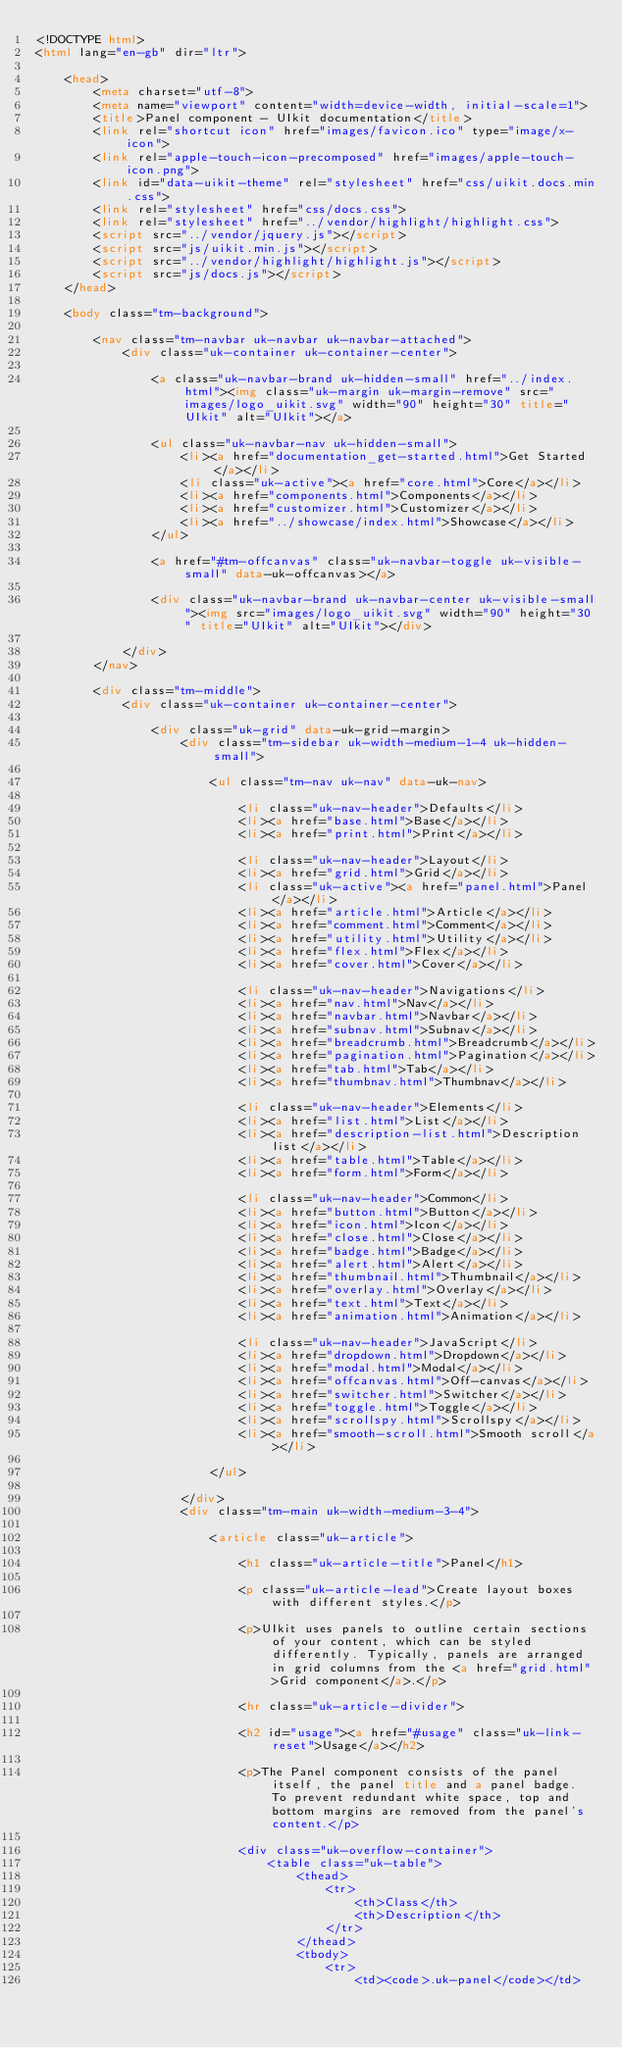<code> <loc_0><loc_0><loc_500><loc_500><_HTML_><!DOCTYPE html>
<html lang="en-gb" dir="ltr">

    <head>
        <meta charset="utf-8">
        <meta name="viewport" content="width=device-width, initial-scale=1">
        <title>Panel component - UIkit documentation</title>
        <link rel="shortcut icon" href="images/favicon.ico" type="image/x-icon">
        <link rel="apple-touch-icon-precomposed" href="images/apple-touch-icon.png">
        <link id="data-uikit-theme" rel="stylesheet" href="css/uikit.docs.min.css">
        <link rel="stylesheet" href="css/docs.css">
        <link rel="stylesheet" href="../vendor/highlight/highlight.css">
        <script src="../vendor/jquery.js"></script>
        <script src="js/uikit.min.js"></script>
        <script src="../vendor/highlight/highlight.js"></script>
        <script src="js/docs.js"></script>
    </head>

    <body class="tm-background">

        <nav class="tm-navbar uk-navbar uk-navbar-attached">
            <div class="uk-container uk-container-center">

                <a class="uk-navbar-brand uk-hidden-small" href="../index.html"><img class="uk-margin uk-margin-remove" src="images/logo_uikit.svg" width="90" height="30" title="UIkit" alt="UIkit"></a>

                <ul class="uk-navbar-nav uk-hidden-small">
                    <li><a href="documentation_get-started.html">Get Started</a></li>
                    <li class="uk-active"><a href="core.html">Core</a></li>
                    <li><a href="components.html">Components</a></li>
                    <li><a href="customizer.html">Customizer</a></li>
                    <li><a href="../showcase/index.html">Showcase</a></li>
                </ul>

                <a href="#tm-offcanvas" class="uk-navbar-toggle uk-visible-small" data-uk-offcanvas></a>

                <div class="uk-navbar-brand uk-navbar-center uk-visible-small"><img src="images/logo_uikit.svg" width="90" height="30" title="UIkit" alt="UIkit"></div>

            </div>
        </nav>

        <div class="tm-middle">
            <div class="uk-container uk-container-center">

                <div class="uk-grid" data-uk-grid-margin>
                    <div class="tm-sidebar uk-width-medium-1-4 uk-hidden-small">

                        <ul class="tm-nav uk-nav" data-uk-nav>

                            <li class="uk-nav-header">Defaults</li>
                            <li><a href="base.html">Base</a></li>
                            <li><a href="print.html">Print</a></li>

                            <li class="uk-nav-header">Layout</li>
                            <li><a href="grid.html">Grid</a></li>
                            <li class="uk-active"><a href="panel.html">Panel</a></li>
                            <li><a href="article.html">Article</a></li>
                            <li><a href="comment.html">Comment</a></li>
                            <li><a href="utility.html">Utility</a></li>
                            <li><a href="flex.html">Flex</a></li>
                            <li><a href="cover.html">Cover</a></li>

                            <li class="uk-nav-header">Navigations</li>
                            <li><a href="nav.html">Nav</a></li>
                            <li><a href="navbar.html">Navbar</a></li>
                            <li><a href="subnav.html">Subnav</a></li>
                            <li><a href="breadcrumb.html">Breadcrumb</a></li>
                            <li><a href="pagination.html">Pagination</a></li>
                            <li><a href="tab.html">Tab</a></li>
                            <li><a href="thumbnav.html">Thumbnav</a></li>

                            <li class="uk-nav-header">Elements</li>
                            <li><a href="list.html">List</a></li>
                            <li><a href="description-list.html">Description list</a></li>
                            <li><a href="table.html">Table</a></li>
                            <li><a href="form.html">Form</a></li>

                            <li class="uk-nav-header">Common</li>
                            <li><a href="button.html">Button</a></li>
                            <li><a href="icon.html">Icon</a></li>
                            <li><a href="close.html">Close</a></li>
                            <li><a href="badge.html">Badge</a></li>
                            <li><a href="alert.html">Alert</a></li>
                            <li><a href="thumbnail.html">Thumbnail</a></li>
                            <li><a href="overlay.html">Overlay</a></li>
                            <li><a href="text.html">Text</a></li>
                            <li><a href="animation.html">Animation</a></li>

                            <li class="uk-nav-header">JavaScript</li>
                            <li><a href="dropdown.html">Dropdown</a></li>
                            <li><a href="modal.html">Modal</a></li>
                            <li><a href="offcanvas.html">Off-canvas</a></li>
                            <li><a href="switcher.html">Switcher</a></li>
                            <li><a href="toggle.html">Toggle</a></li>
                            <li><a href="scrollspy.html">Scrollspy</a></li>
                            <li><a href="smooth-scroll.html">Smooth scroll</a></li>

                        </ul>

                    </div>
                    <div class="tm-main uk-width-medium-3-4">

                        <article class="uk-article">

                            <h1 class="uk-article-title">Panel</h1>

                            <p class="uk-article-lead">Create layout boxes with different styles.</p>

                            <p>UIkit uses panels to outline certain sections of your content, which can be styled differently. Typically, panels are arranged in grid columns from the <a href="grid.html">Grid component</a>.</p>

                            <hr class="uk-article-divider">

                            <h2 id="usage"><a href="#usage" class="uk-link-reset">Usage</a></h2>

                            <p>The Panel component consists of the panel itself, the panel title and a panel badge. To prevent redundant white space, top and bottom margins are removed from the panel's content.</p>

                            <div class="uk-overflow-container">
                                <table class="uk-table">
                                    <thead>
                                        <tr>
                                            <th>Class</th>
                                            <th>Description</th>
                                        </tr>
                                    </thead>
                                    <tbody>
                                        <tr>
                                            <td><code>.uk-panel</code></td></code> 